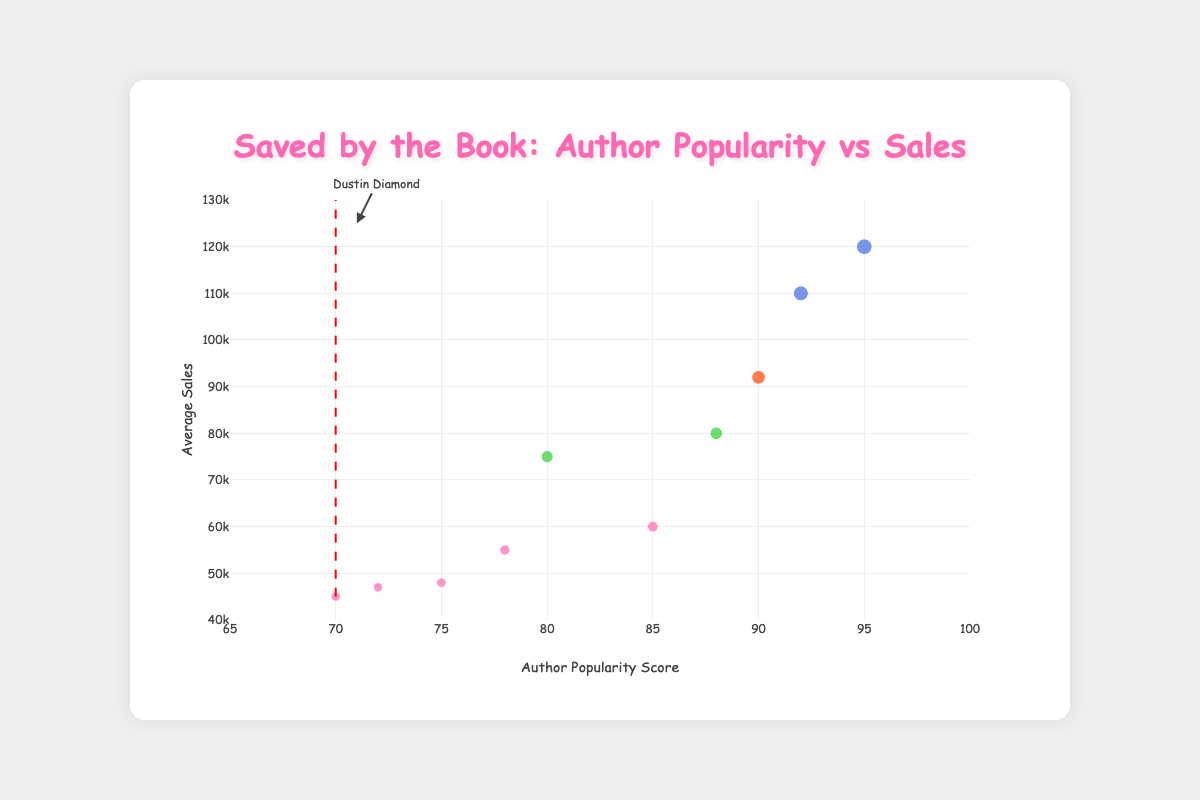What is the average sales figure for Dustin Diamond's book? Look at the bubble representing Dustin Diamond in the "Memoir" genre. The text annotation shows "Sales: 45000".
Answer: 45000 What is the title of the chart? The title is displayed at the top of the chart in a header.
Answer: Saved by the Book: Author Popularity vs Sales Which genre has the bubble with the highest average sales? The genre with the highest average sales bubble is indicated by its color and size. The largest bubble, which is blue, represents "Fiction" with J.K. Rowling's sales at 120,000.
Answer: Fiction How many authors are in the "Memoir" genre in this chart? Count the number of bubbles with the color representing "Memoir". There are five bubbles: Dustin Diamond, Jimmy Fallon, Tiffani Thiessen, Mario Lopez, and Elizabeth Berkley.
Answer: 5 Which author has the highest popularity score and what is the score? Look for the bubble positioned furthest to the right on the x-axis (popularity score). J.K. Rowling has the highest popularity score of 95.
Answer: J.K. Rowling, 95 Compare the average sales of Dustin Diamond and Mario Lopez. Locate Dustin Diamond's average sales (45000) and Mario Lopez's average sales (55000) on the y-axis. Determine the difference: 55000 - 45000.
Answer: Mario Lopez's sales are 10000 higher Which author has a higher popularity score, Mark Manson or Brené Brown, and by how much? Find the popularity scores: Mark Manson (80) and Brené Brown (88). Subtract the lower score from the higher one: 88 - 80.
Answer: Brené Brown by 8 Which genres have bubbles that are above the red dash line indicating the popularity score of 70? Identify bubbles with x-values greater than 70. Genres include Memoir, Fiction, Self-Help, and True Crime.
Answer: Memoir, Fiction, Self-Help, True Crime Which genre is represented by the bubble closest to the average sales of 55000? Identify the bubble closest to y-value 55000 on the average sales axis. The closest matching bubble represents "Memoir" (Mario Lopez's sales).
Answer: Memoir 